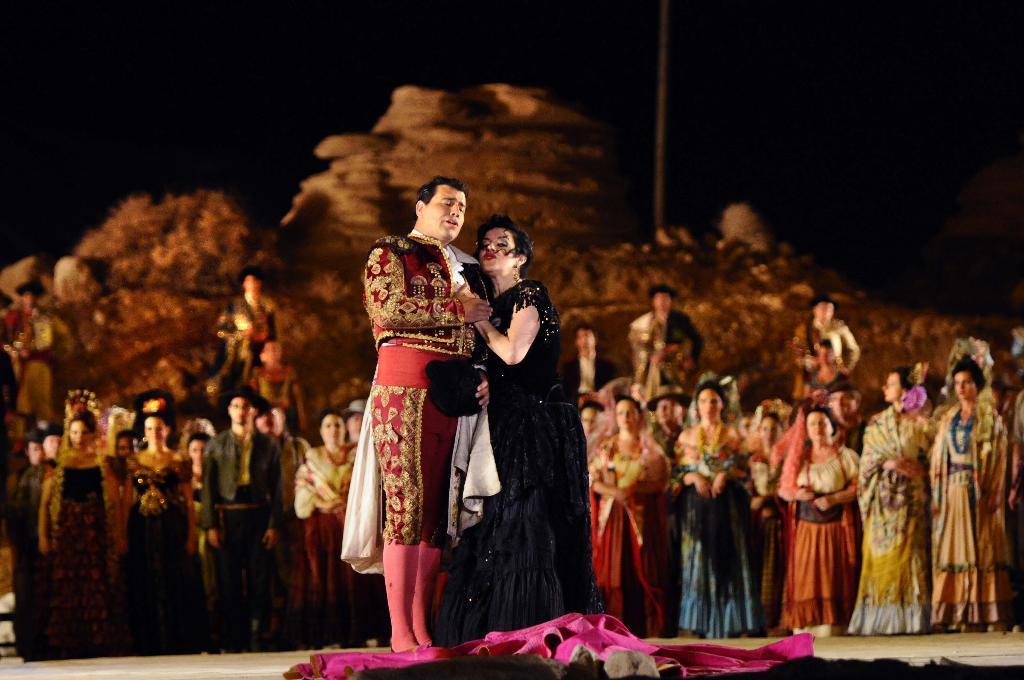Describe this image in one or two sentences. There is a man and a woman standing. On the ground there is a pink cloth. In the background there is a crowd. Also it is dark in the background. 